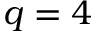Convert formula to latex. <formula><loc_0><loc_0><loc_500><loc_500>q = 4</formula> 